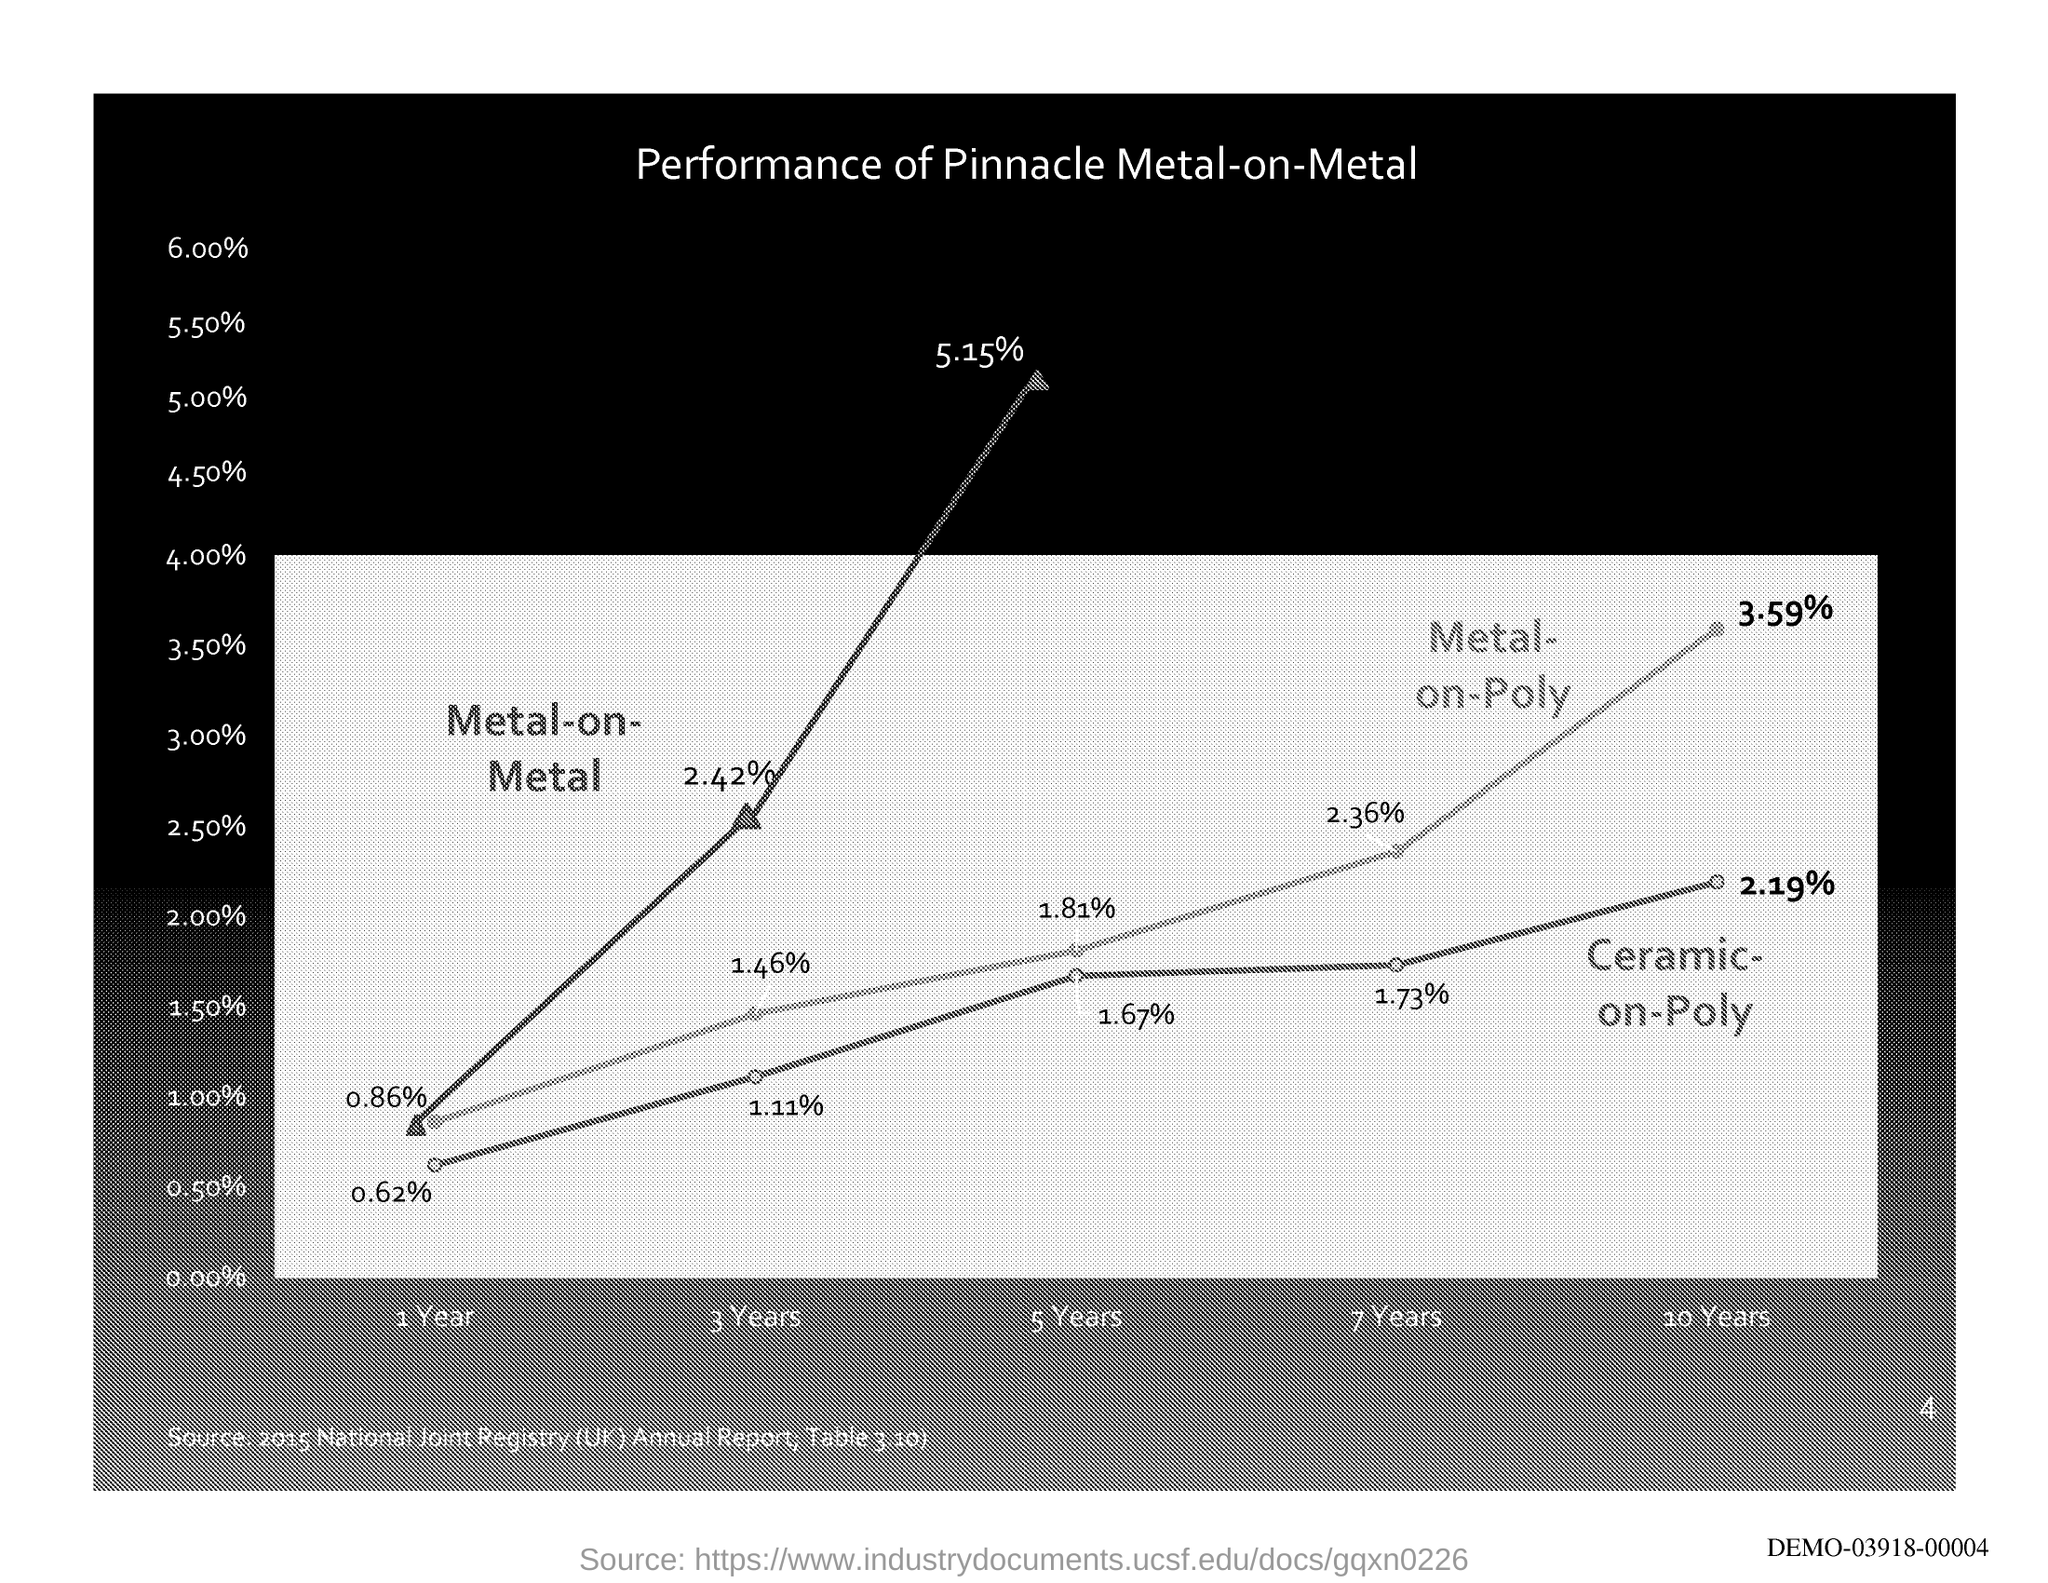What is the title of the graph?
Keep it short and to the point. Performance of Pinnacle Metal-on-Metal. What is the source of the graph?
Keep it short and to the point. 2015 National Joint Registry (UK) Annual Report; Table 3.10). What is the unit on X axis?
Your answer should be very brief. Year. What is the unit on Y axis?
Your answer should be compact. %. 